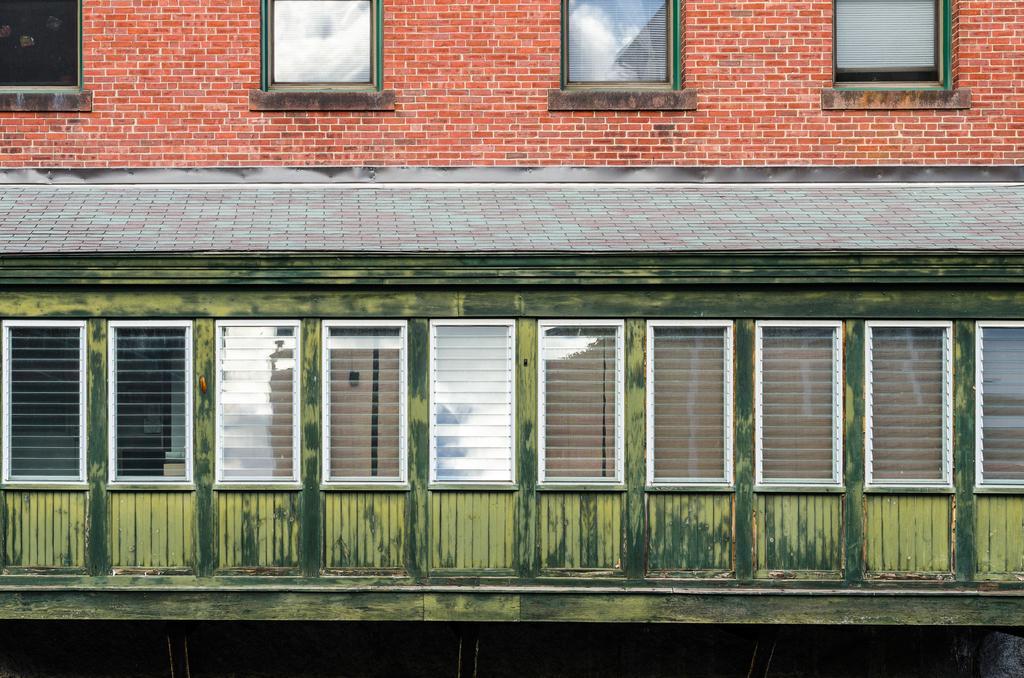Could you give a brief overview of what you see in this image? In this picture we can see a building with windows, curtains, brick wall. 